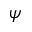Convert formula to latex. <formula><loc_0><loc_0><loc_500><loc_500>\psi</formula> 